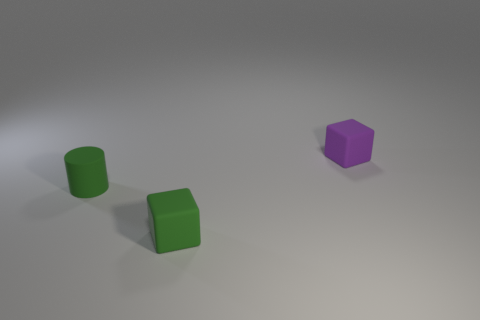Subtract all blue cylinders. Subtract all gray blocks. How many cylinders are left? 1 Add 2 tiny brown metallic balls. How many objects exist? 5 Subtract all cylinders. How many objects are left? 2 Subtract 0 brown cubes. How many objects are left? 3 Subtract all large yellow rubber cylinders. Subtract all small purple matte cubes. How many objects are left? 2 Add 1 tiny green rubber cylinders. How many tiny green rubber cylinders are left? 2 Add 1 small purple matte objects. How many small purple matte objects exist? 2 